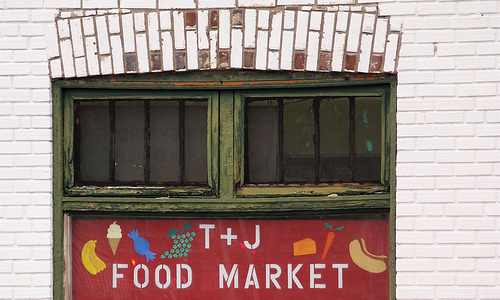<image>
Can you confirm if the sign is under the window? Yes. The sign is positioned underneath the window, with the window above it in the vertical space. Is the window in the wood? Yes. The window is contained within or inside the wood, showing a containment relationship. 